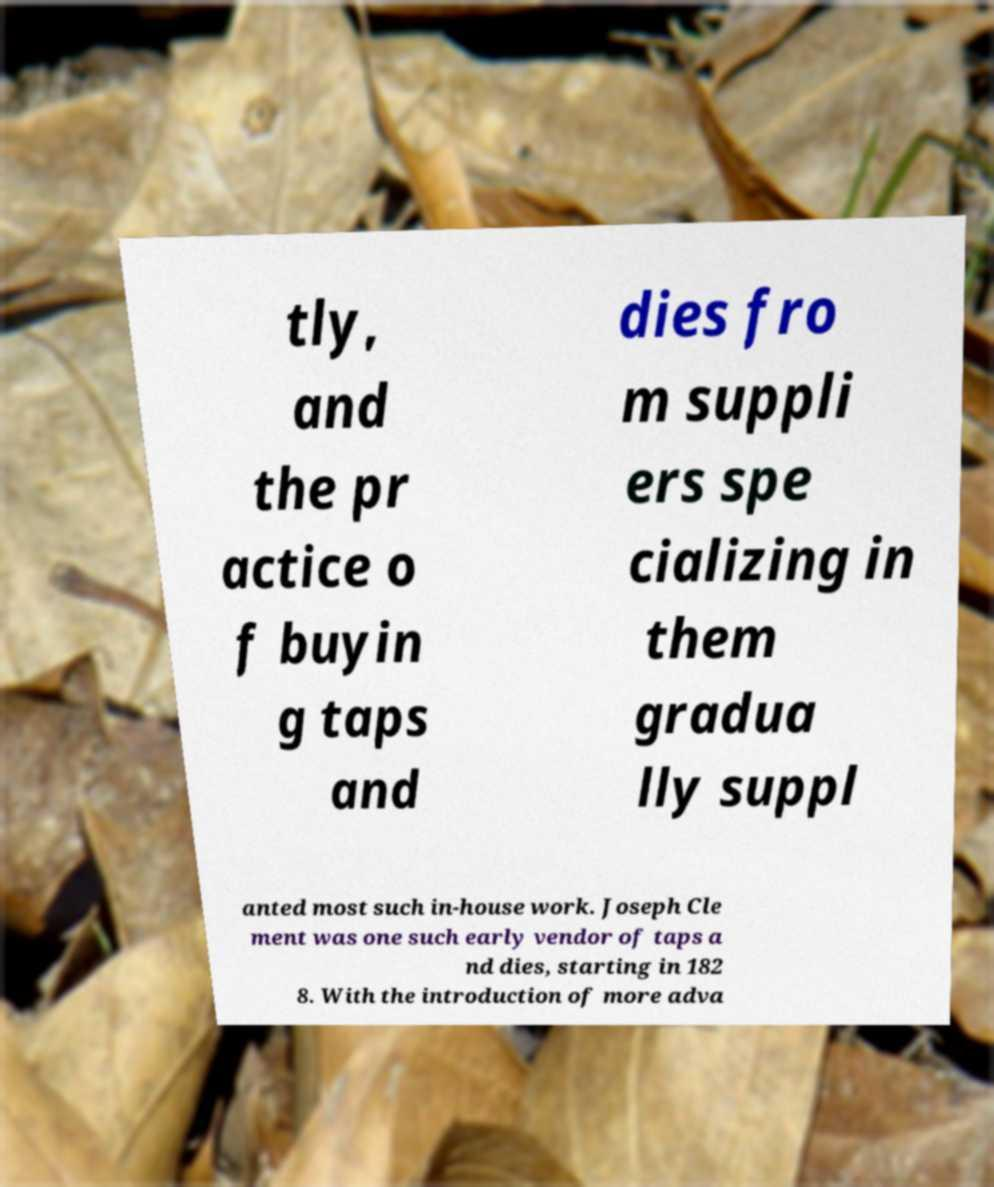For documentation purposes, I need the text within this image transcribed. Could you provide that? tly, and the pr actice o f buyin g taps and dies fro m suppli ers spe cializing in them gradua lly suppl anted most such in-house work. Joseph Cle ment was one such early vendor of taps a nd dies, starting in 182 8. With the introduction of more adva 